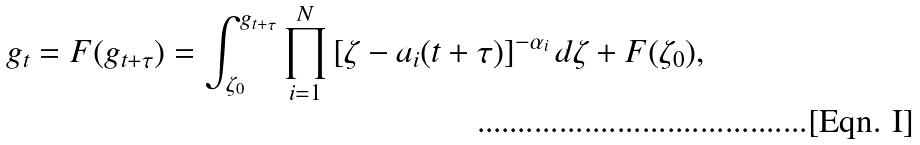Convert formula to latex. <formula><loc_0><loc_0><loc_500><loc_500>g _ { t } = F ( g _ { t + \tau } ) = \int _ { \zeta _ { 0 } } ^ { g _ { t + \tau } } \prod _ { i = 1 } ^ { N } { [ \zeta - a _ { i } ( t + \tau ) ] ^ { - \alpha _ { i } } } \, d \zeta + F ( \zeta _ { 0 } ) ,</formula> 